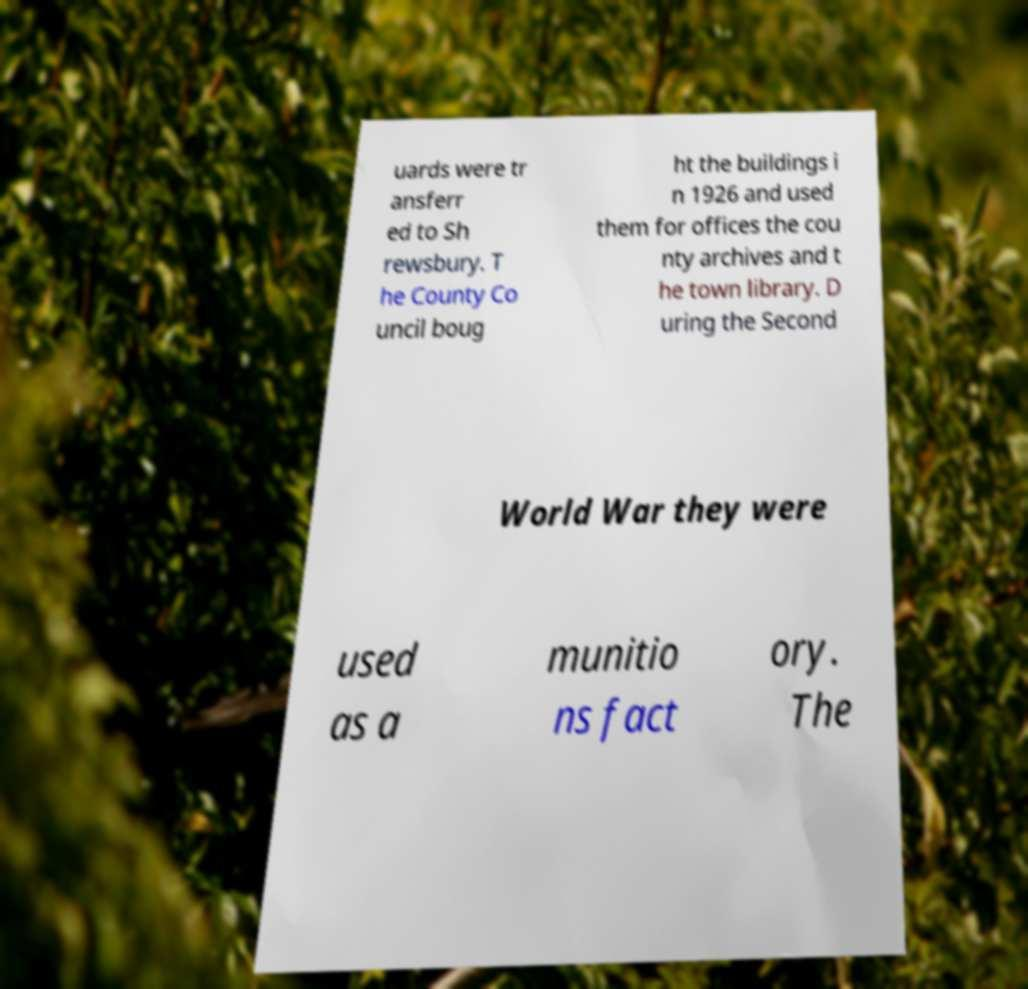What messages or text are displayed in this image? I need them in a readable, typed format. uards were tr ansferr ed to Sh rewsbury. T he County Co uncil boug ht the buildings i n 1926 and used them for offices the cou nty archives and t he town library. D uring the Second World War they were used as a munitio ns fact ory. The 